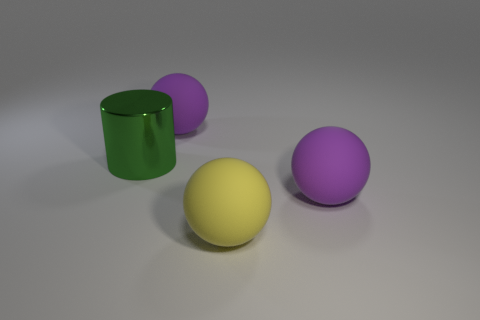Can you describe the lighting and mood of the scene? The scene is lit with soft, diffused lighting that casts subtle shadows beneath the objects, giving a sense of depth and dimension to the composition. The lighting contributes to a calm and tranquil mood, with the neutral background allowing the colors of the objects to stand out clearly. There are no harsh shadows or bright highlights, which helps maintain a harmonious and gentle atmosphere. 